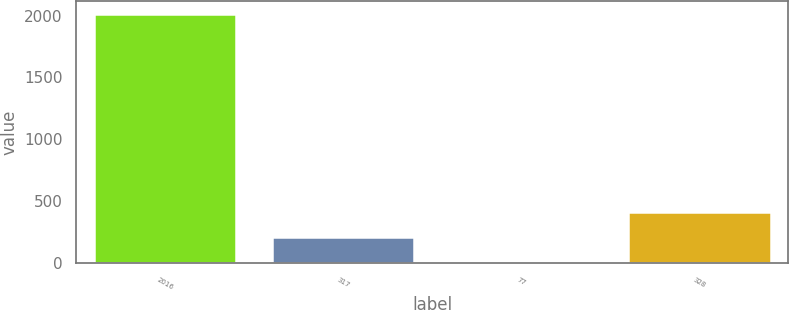Convert chart to OTSL. <chart><loc_0><loc_0><loc_500><loc_500><bar_chart><fcel>2016<fcel>317<fcel>77<fcel>328<nl><fcel>2015<fcel>208.79<fcel>8.1<fcel>409.48<nl></chart> 